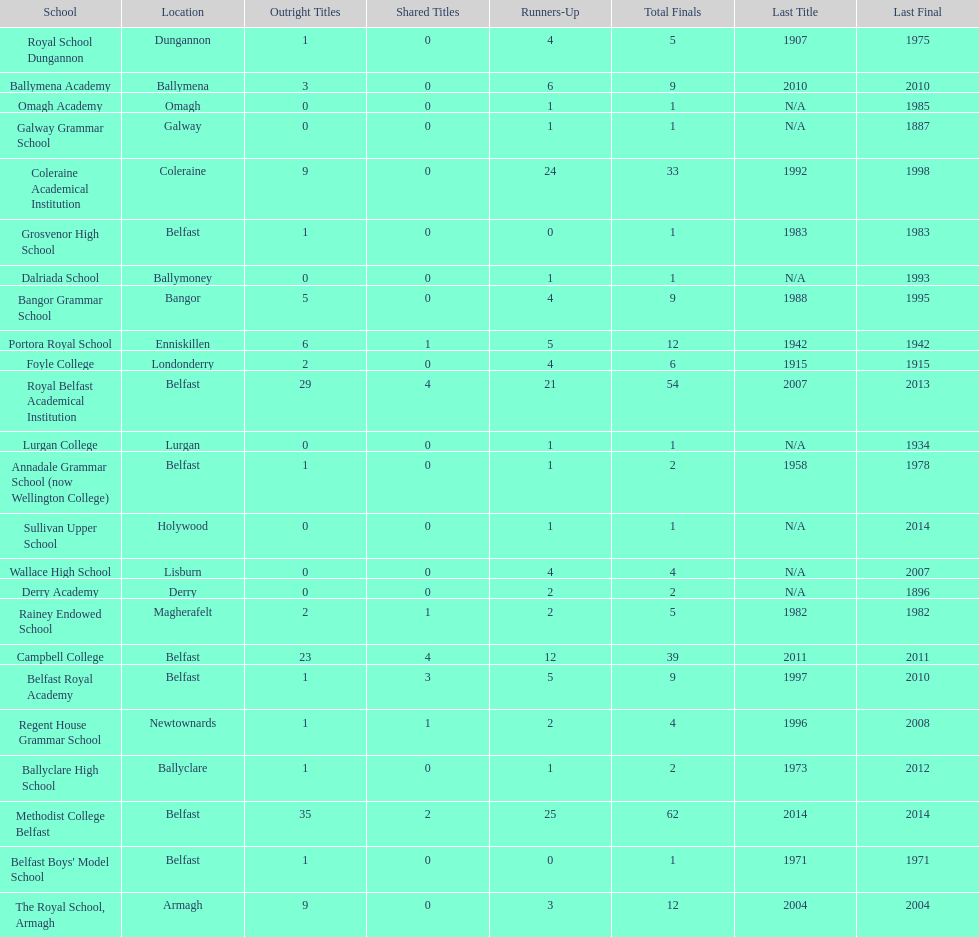How many schools had above 5 outright titles? 6. 